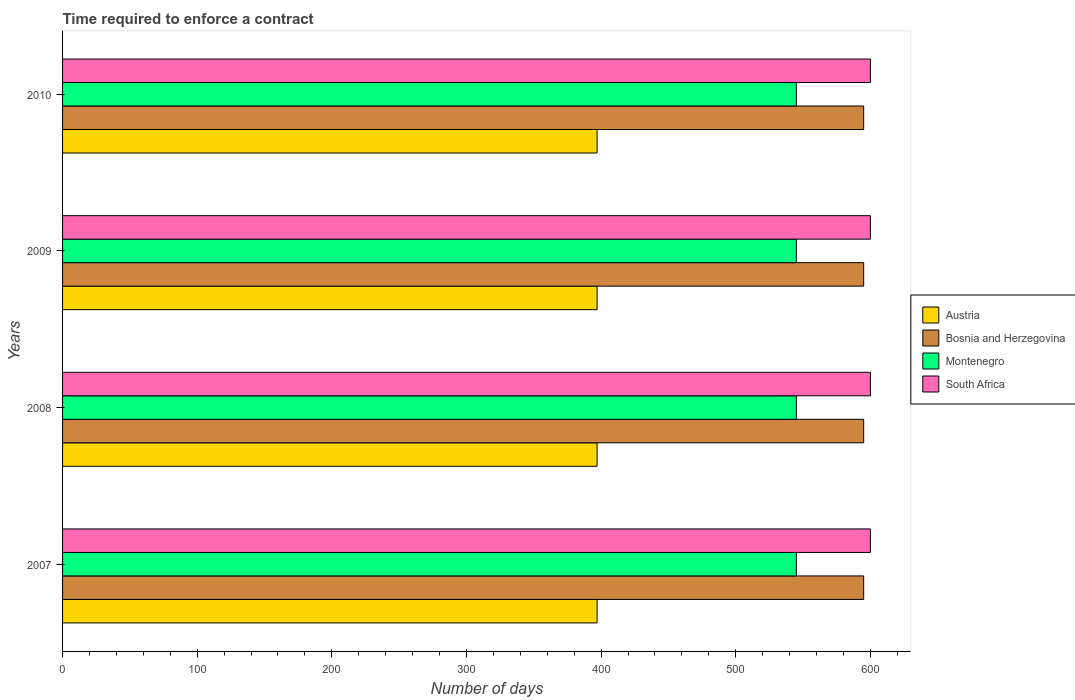Are the number of bars per tick equal to the number of legend labels?
Offer a very short reply. Yes. Are the number of bars on each tick of the Y-axis equal?
Your response must be concise. Yes. How many bars are there on the 3rd tick from the bottom?
Your answer should be compact. 4. What is the number of days required to enforce a contract in Austria in 2009?
Give a very brief answer. 397. Across all years, what is the maximum number of days required to enforce a contract in Bosnia and Herzegovina?
Offer a terse response. 595. Across all years, what is the minimum number of days required to enforce a contract in Montenegro?
Offer a terse response. 545. What is the total number of days required to enforce a contract in Bosnia and Herzegovina in the graph?
Your answer should be very brief. 2380. What is the difference between the number of days required to enforce a contract in South Africa in 2009 and the number of days required to enforce a contract in Austria in 2007?
Your answer should be compact. 203. What is the average number of days required to enforce a contract in Austria per year?
Keep it short and to the point. 397. In the year 2009, what is the difference between the number of days required to enforce a contract in Bosnia and Herzegovina and number of days required to enforce a contract in Austria?
Your answer should be very brief. 198. What is the ratio of the number of days required to enforce a contract in Bosnia and Herzegovina in 2007 to that in 2010?
Offer a terse response. 1. Is the difference between the number of days required to enforce a contract in Bosnia and Herzegovina in 2007 and 2010 greater than the difference between the number of days required to enforce a contract in Austria in 2007 and 2010?
Ensure brevity in your answer.  No. In how many years, is the number of days required to enforce a contract in Montenegro greater than the average number of days required to enforce a contract in Montenegro taken over all years?
Make the answer very short. 0. Is the sum of the number of days required to enforce a contract in Bosnia and Herzegovina in 2007 and 2009 greater than the maximum number of days required to enforce a contract in Montenegro across all years?
Offer a terse response. Yes. Is it the case that in every year, the sum of the number of days required to enforce a contract in Bosnia and Herzegovina and number of days required to enforce a contract in Montenegro is greater than the sum of number of days required to enforce a contract in Austria and number of days required to enforce a contract in South Africa?
Ensure brevity in your answer.  Yes. What does the 1st bar from the top in 2007 represents?
Your answer should be compact. South Africa. What does the 1st bar from the bottom in 2010 represents?
Your response must be concise. Austria. Is it the case that in every year, the sum of the number of days required to enforce a contract in Austria and number of days required to enforce a contract in Montenegro is greater than the number of days required to enforce a contract in South Africa?
Ensure brevity in your answer.  Yes. Does the graph contain any zero values?
Offer a very short reply. No. Does the graph contain grids?
Your answer should be compact. No. How many legend labels are there?
Your answer should be very brief. 4. What is the title of the graph?
Give a very brief answer. Time required to enforce a contract. Does "Djibouti" appear as one of the legend labels in the graph?
Offer a very short reply. No. What is the label or title of the X-axis?
Ensure brevity in your answer.  Number of days. What is the label or title of the Y-axis?
Offer a terse response. Years. What is the Number of days in Austria in 2007?
Your answer should be compact. 397. What is the Number of days of Bosnia and Herzegovina in 2007?
Provide a succinct answer. 595. What is the Number of days in Montenegro in 2007?
Provide a short and direct response. 545. What is the Number of days of South Africa in 2007?
Give a very brief answer. 600. What is the Number of days in Austria in 2008?
Your answer should be compact. 397. What is the Number of days of Bosnia and Herzegovina in 2008?
Your response must be concise. 595. What is the Number of days in Montenegro in 2008?
Keep it short and to the point. 545. What is the Number of days of South Africa in 2008?
Your answer should be compact. 600. What is the Number of days in Austria in 2009?
Offer a terse response. 397. What is the Number of days of Bosnia and Herzegovina in 2009?
Give a very brief answer. 595. What is the Number of days in Montenegro in 2009?
Keep it short and to the point. 545. What is the Number of days in South Africa in 2009?
Your response must be concise. 600. What is the Number of days of Austria in 2010?
Provide a short and direct response. 397. What is the Number of days in Bosnia and Herzegovina in 2010?
Provide a succinct answer. 595. What is the Number of days of Montenegro in 2010?
Your answer should be very brief. 545. What is the Number of days in South Africa in 2010?
Keep it short and to the point. 600. Across all years, what is the maximum Number of days in Austria?
Your response must be concise. 397. Across all years, what is the maximum Number of days of Bosnia and Herzegovina?
Your answer should be very brief. 595. Across all years, what is the maximum Number of days of Montenegro?
Your response must be concise. 545. Across all years, what is the maximum Number of days in South Africa?
Ensure brevity in your answer.  600. Across all years, what is the minimum Number of days of Austria?
Provide a succinct answer. 397. Across all years, what is the minimum Number of days in Bosnia and Herzegovina?
Your answer should be compact. 595. Across all years, what is the minimum Number of days in Montenegro?
Give a very brief answer. 545. Across all years, what is the minimum Number of days in South Africa?
Offer a very short reply. 600. What is the total Number of days in Austria in the graph?
Offer a terse response. 1588. What is the total Number of days in Bosnia and Herzegovina in the graph?
Your response must be concise. 2380. What is the total Number of days in Montenegro in the graph?
Your answer should be very brief. 2180. What is the total Number of days of South Africa in the graph?
Give a very brief answer. 2400. What is the difference between the Number of days in Bosnia and Herzegovina in 2007 and that in 2008?
Provide a succinct answer. 0. What is the difference between the Number of days of Montenegro in 2007 and that in 2008?
Ensure brevity in your answer.  0. What is the difference between the Number of days of South Africa in 2007 and that in 2008?
Offer a very short reply. 0. What is the difference between the Number of days in Montenegro in 2007 and that in 2009?
Provide a short and direct response. 0. What is the difference between the Number of days of South Africa in 2007 and that in 2009?
Your response must be concise. 0. What is the difference between the Number of days in Bosnia and Herzegovina in 2007 and that in 2010?
Give a very brief answer. 0. What is the difference between the Number of days of Montenegro in 2007 and that in 2010?
Make the answer very short. 0. What is the difference between the Number of days in South Africa in 2008 and that in 2009?
Provide a succinct answer. 0. What is the difference between the Number of days of Austria in 2008 and that in 2010?
Give a very brief answer. 0. What is the difference between the Number of days of Montenegro in 2008 and that in 2010?
Offer a terse response. 0. What is the difference between the Number of days in South Africa in 2008 and that in 2010?
Provide a short and direct response. 0. What is the difference between the Number of days in South Africa in 2009 and that in 2010?
Provide a short and direct response. 0. What is the difference between the Number of days in Austria in 2007 and the Number of days in Bosnia and Herzegovina in 2008?
Your answer should be compact. -198. What is the difference between the Number of days in Austria in 2007 and the Number of days in Montenegro in 2008?
Provide a short and direct response. -148. What is the difference between the Number of days in Austria in 2007 and the Number of days in South Africa in 2008?
Provide a short and direct response. -203. What is the difference between the Number of days of Bosnia and Herzegovina in 2007 and the Number of days of Montenegro in 2008?
Keep it short and to the point. 50. What is the difference between the Number of days of Bosnia and Herzegovina in 2007 and the Number of days of South Africa in 2008?
Ensure brevity in your answer.  -5. What is the difference between the Number of days of Montenegro in 2007 and the Number of days of South Africa in 2008?
Keep it short and to the point. -55. What is the difference between the Number of days in Austria in 2007 and the Number of days in Bosnia and Herzegovina in 2009?
Your answer should be very brief. -198. What is the difference between the Number of days of Austria in 2007 and the Number of days of Montenegro in 2009?
Make the answer very short. -148. What is the difference between the Number of days of Austria in 2007 and the Number of days of South Africa in 2009?
Offer a terse response. -203. What is the difference between the Number of days in Bosnia and Herzegovina in 2007 and the Number of days in South Africa in 2009?
Your answer should be compact. -5. What is the difference between the Number of days of Montenegro in 2007 and the Number of days of South Africa in 2009?
Keep it short and to the point. -55. What is the difference between the Number of days of Austria in 2007 and the Number of days of Bosnia and Herzegovina in 2010?
Offer a very short reply. -198. What is the difference between the Number of days in Austria in 2007 and the Number of days in Montenegro in 2010?
Ensure brevity in your answer.  -148. What is the difference between the Number of days in Austria in 2007 and the Number of days in South Africa in 2010?
Offer a terse response. -203. What is the difference between the Number of days in Bosnia and Herzegovina in 2007 and the Number of days in Montenegro in 2010?
Keep it short and to the point. 50. What is the difference between the Number of days in Montenegro in 2007 and the Number of days in South Africa in 2010?
Ensure brevity in your answer.  -55. What is the difference between the Number of days in Austria in 2008 and the Number of days in Bosnia and Herzegovina in 2009?
Give a very brief answer. -198. What is the difference between the Number of days of Austria in 2008 and the Number of days of Montenegro in 2009?
Offer a very short reply. -148. What is the difference between the Number of days of Austria in 2008 and the Number of days of South Africa in 2009?
Offer a very short reply. -203. What is the difference between the Number of days in Bosnia and Herzegovina in 2008 and the Number of days in South Africa in 2009?
Ensure brevity in your answer.  -5. What is the difference between the Number of days of Montenegro in 2008 and the Number of days of South Africa in 2009?
Ensure brevity in your answer.  -55. What is the difference between the Number of days of Austria in 2008 and the Number of days of Bosnia and Herzegovina in 2010?
Your answer should be compact. -198. What is the difference between the Number of days of Austria in 2008 and the Number of days of Montenegro in 2010?
Make the answer very short. -148. What is the difference between the Number of days in Austria in 2008 and the Number of days in South Africa in 2010?
Provide a short and direct response. -203. What is the difference between the Number of days of Bosnia and Herzegovina in 2008 and the Number of days of Montenegro in 2010?
Provide a succinct answer. 50. What is the difference between the Number of days in Bosnia and Herzegovina in 2008 and the Number of days in South Africa in 2010?
Offer a very short reply. -5. What is the difference between the Number of days of Montenegro in 2008 and the Number of days of South Africa in 2010?
Make the answer very short. -55. What is the difference between the Number of days of Austria in 2009 and the Number of days of Bosnia and Herzegovina in 2010?
Give a very brief answer. -198. What is the difference between the Number of days of Austria in 2009 and the Number of days of Montenegro in 2010?
Your answer should be very brief. -148. What is the difference between the Number of days in Austria in 2009 and the Number of days in South Africa in 2010?
Keep it short and to the point. -203. What is the difference between the Number of days in Bosnia and Herzegovina in 2009 and the Number of days in Montenegro in 2010?
Your answer should be compact. 50. What is the difference between the Number of days in Bosnia and Herzegovina in 2009 and the Number of days in South Africa in 2010?
Make the answer very short. -5. What is the difference between the Number of days in Montenegro in 2009 and the Number of days in South Africa in 2010?
Keep it short and to the point. -55. What is the average Number of days of Austria per year?
Keep it short and to the point. 397. What is the average Number of days in Bosnia and Herzegovina per year?
Provide a short and direct response. 595. What is the average Number of days in Montenegro per year?
Your answer should be very brief. 545. What is the average Number of days in South Africa per year?
Make the answer very short. 600. In the year 2007, what is the difference between the Number of days of Austria and Number of days of Bosnia and Herzegovina?
Provide a succinct answer. -198. In the year 2007, what is the difference between the Number of days of Austria and Number of days of Montenegro?
Keep it short and to the point. -148. In the year 2007, what is the difference between the Number of days in Austria and Number of days in South Africa?
Provide a succinct answer. -203. In the year 2007, what is the difference between the Number of days of Montenegro and Number of days of South Africa?
Give a very brief answer. -55. In the year 2008, what is the difference between the Number of days of Austria and Number of days of Bosnia and Herzegovina?
Your response must be concise. -198. In the year 2008, what is the difference between the Number of days in Austria and Number of days in Montenegro?
Your answer should be very brief. -148. In the year 2008, what is the difference between the Number of days in Austria and Number of days in South Africa?
Give a very brief answer. -203. In the year 2008, what is the difference between the Number of days of Bosnia and Herzegovina and Number of days of Montenegro?
Offer a very short reply. 50. In the year 2008, what is the difference between the Number of days of Montenegro and Number of days of South Africa?
Provide a succinct answer. -55. In the year 2009, what is the difference between the Number of days of Austria and Number of days of Bosnia and Herzegovina?
Your response must be concise. -198. In the year 2009, what is the difference between the Number of days of Austria and Number of days of Montenegro?
Make the answer very short. -148. In the year 2009, what is the difference between the Number of days in Austria and Number of days in South Africa?
Keep it short and to the point. -203. In the year 2009, what is the difference between the Number of days of Montenegro and Number of days of South Africa?
Your answer should be compact. -55. In the year 2010, what is the difference between the Number of days in Austria and Number of days in Bosnia and Herzegovina?
Offer a very short reply. -198. In the year 2010, what is the difference between the Number of days of Austria and Number of days of Montenegro?
Keep it short and to the point. -148. In the year 2010, what is the difference between the Number of days of Austria and Number of days of South Africa?
Ensure brevity in your answer.  -203. In the year 2010, what is the difference between the Number of days of Bosnia and Herzegovina and Number of days of Montenegro?
Provide a succinct answer. 50. In the year 2010, what is the difference between the Number of days of Bosnia and Herzegovina and Number of days of South Africa?
Keep it short and to the point. -5. In the year 2010, what is the difference between the Number of days in Montenegro and Number of days in South Africa?
Ensure brevity in your answer.  -55. What is the ratio of the Number of days in Montenegro in 2007 to that in 2008?
Give a very brief answer. 1. What is the ratio of the Number of days in South Africa in 2007 to that in 2008?
Your answer should be compact. 1. What is the ratio of the Number of days of Austria in 2007 to that in 2009?
Provide a succinct answer. 1. What is the ratio of the Number of days in Bosnia and Herzegovina in 2007 to that in 2009?
Provide a short and direct response. 1. What is the ratio of the Number of days of Austria in 2007 to that in 2010?
Provide a succinct answer. 1. What is the ratio of the Number of days of Bosnia and Herzegovina in 2007 to that in 2010?
Provide a succinct answer. 1. What is the ratio of the Number of days in South Africa in 2007 to that in 2010?
Provide a short and direct response. 1. What is the ratio of the Number of days in Montenegro in 2008 to that in 2009?
Make the answer very short. 1. What is the ratio of the Number of days of South Africa in 2008 to that in 2009?
Offer a very short reply. 1. What is the ratio of the Number of days of Austria in 2008 to that in 2010?
Offer a very short reply. 1. What is the ratio of the Number of days of Bosnia and Herzegovina in 2008 to that in 2010?
Provide a succinct answer. 1. What is the ratio of the Number of days in Bosnia and Herzegovina in 2009 to that in 2010?
Keep it short and to the point. 1. What is the ratio of the Number of days of South Africa in 2009 to that in 2010?
Your answer should be very brief. 1. What is the difference between the highest and the second highest Number of days in Austria?
Your answer should be very brief. 0. What is the difference between the highest and the second highest Number of days in Bosnia and Herzegovina?
Provide a succinct answer. 0. What is the difference between the highest and the second highest Number of days of Montenegro?
Provide a short and direct response. 0. What is the difference between the highest and the lowest Number of days of Bosnia and Herzegovina?
Offer a very short reply. 0. What is the difference between the highest and the lowest Number of days in Montenegro?
Keep it short and to the point. 0. 